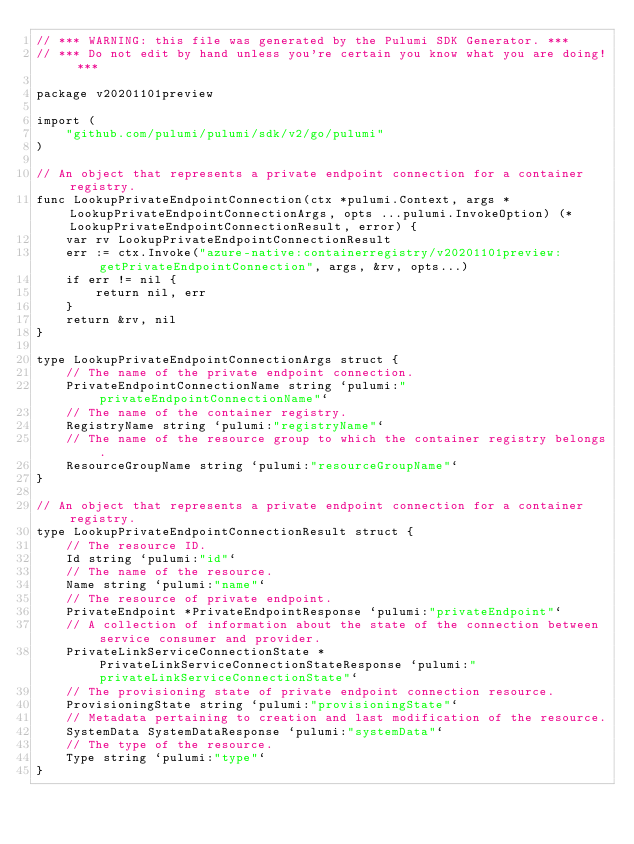<code> <loc_0><loc_0><loc_500><loc_500><_Go_>// *** WARNING: this file was generated by the Pulumi SDK Generator. ***
// *** Do not edit by hand unless you're certain you know what you are doing! ***

package v20201101preview

import (
	"github.com/pulumi/pulumi/sdk/v2/go/pulumi"
)

// An object that represents a private endpoint connection for a container registry.
func LookupPrivateEndpointConnection(ctx *pulumi.Context, args *LookupPrivateEndpointConnectionArgs, opts ...pulumi.InvokeOption) (*LookupPrivateEndpointConnectionResult, error) {
	var rv LookupPrivateEndpointConnectionResult
	err := ctx.Invoke("azure-native:containerregistry/v20201101preview:getPrivateEndpointConnection", args, &rv, opts...)
	if err != nil {
		return nil, err
	}
	return &rv, nil
}

type LookupPrivateEndpointConnectionArgs struct {
	// The name of the private endpoint connection.
	PrivateEndpointConnectionName string `pulumi:"privateEndpointConnectionName"`
	// The name of the container registry.
	RegistryName string `pulumi:"registryName"`
	// The name of the resource group to which the container registry belongs.
	ResourceGroupName string `pulumi:"resourceGroupName"`
}

// An object that represents a private endpoint connection for a container registry.
type LookupPrivateEndpointConnectionResult struct {
	// The resource ID.
	Id string `pulumi:"id"`
	// The name of the resource.
	Name string `pulumi:"name"`
	// The resource of private endpoint.
	PrivateEndpoint *PrivateEndpointResponse `pulumi:"privateEndpoint"`
	// A collection of information about the state of the connection between service consumer and provider.
	PrivateLinkServiceConnectionState *PrivateLinkServiceConnectionStateResponse `pulumi:"privateLinkServiceConnectionState"`
	// The provisioning state of private endpoint connection resource.
	ProvisioningState string `pulumi:"provisioningState"`
	// Metadata pertaining to creation and last modification of the resource.
	SystemData SystemDataResponse `pulumi:"systemData"`
	// The type of the resource.
	Type string `pulumi:"type"`
}
</code> 